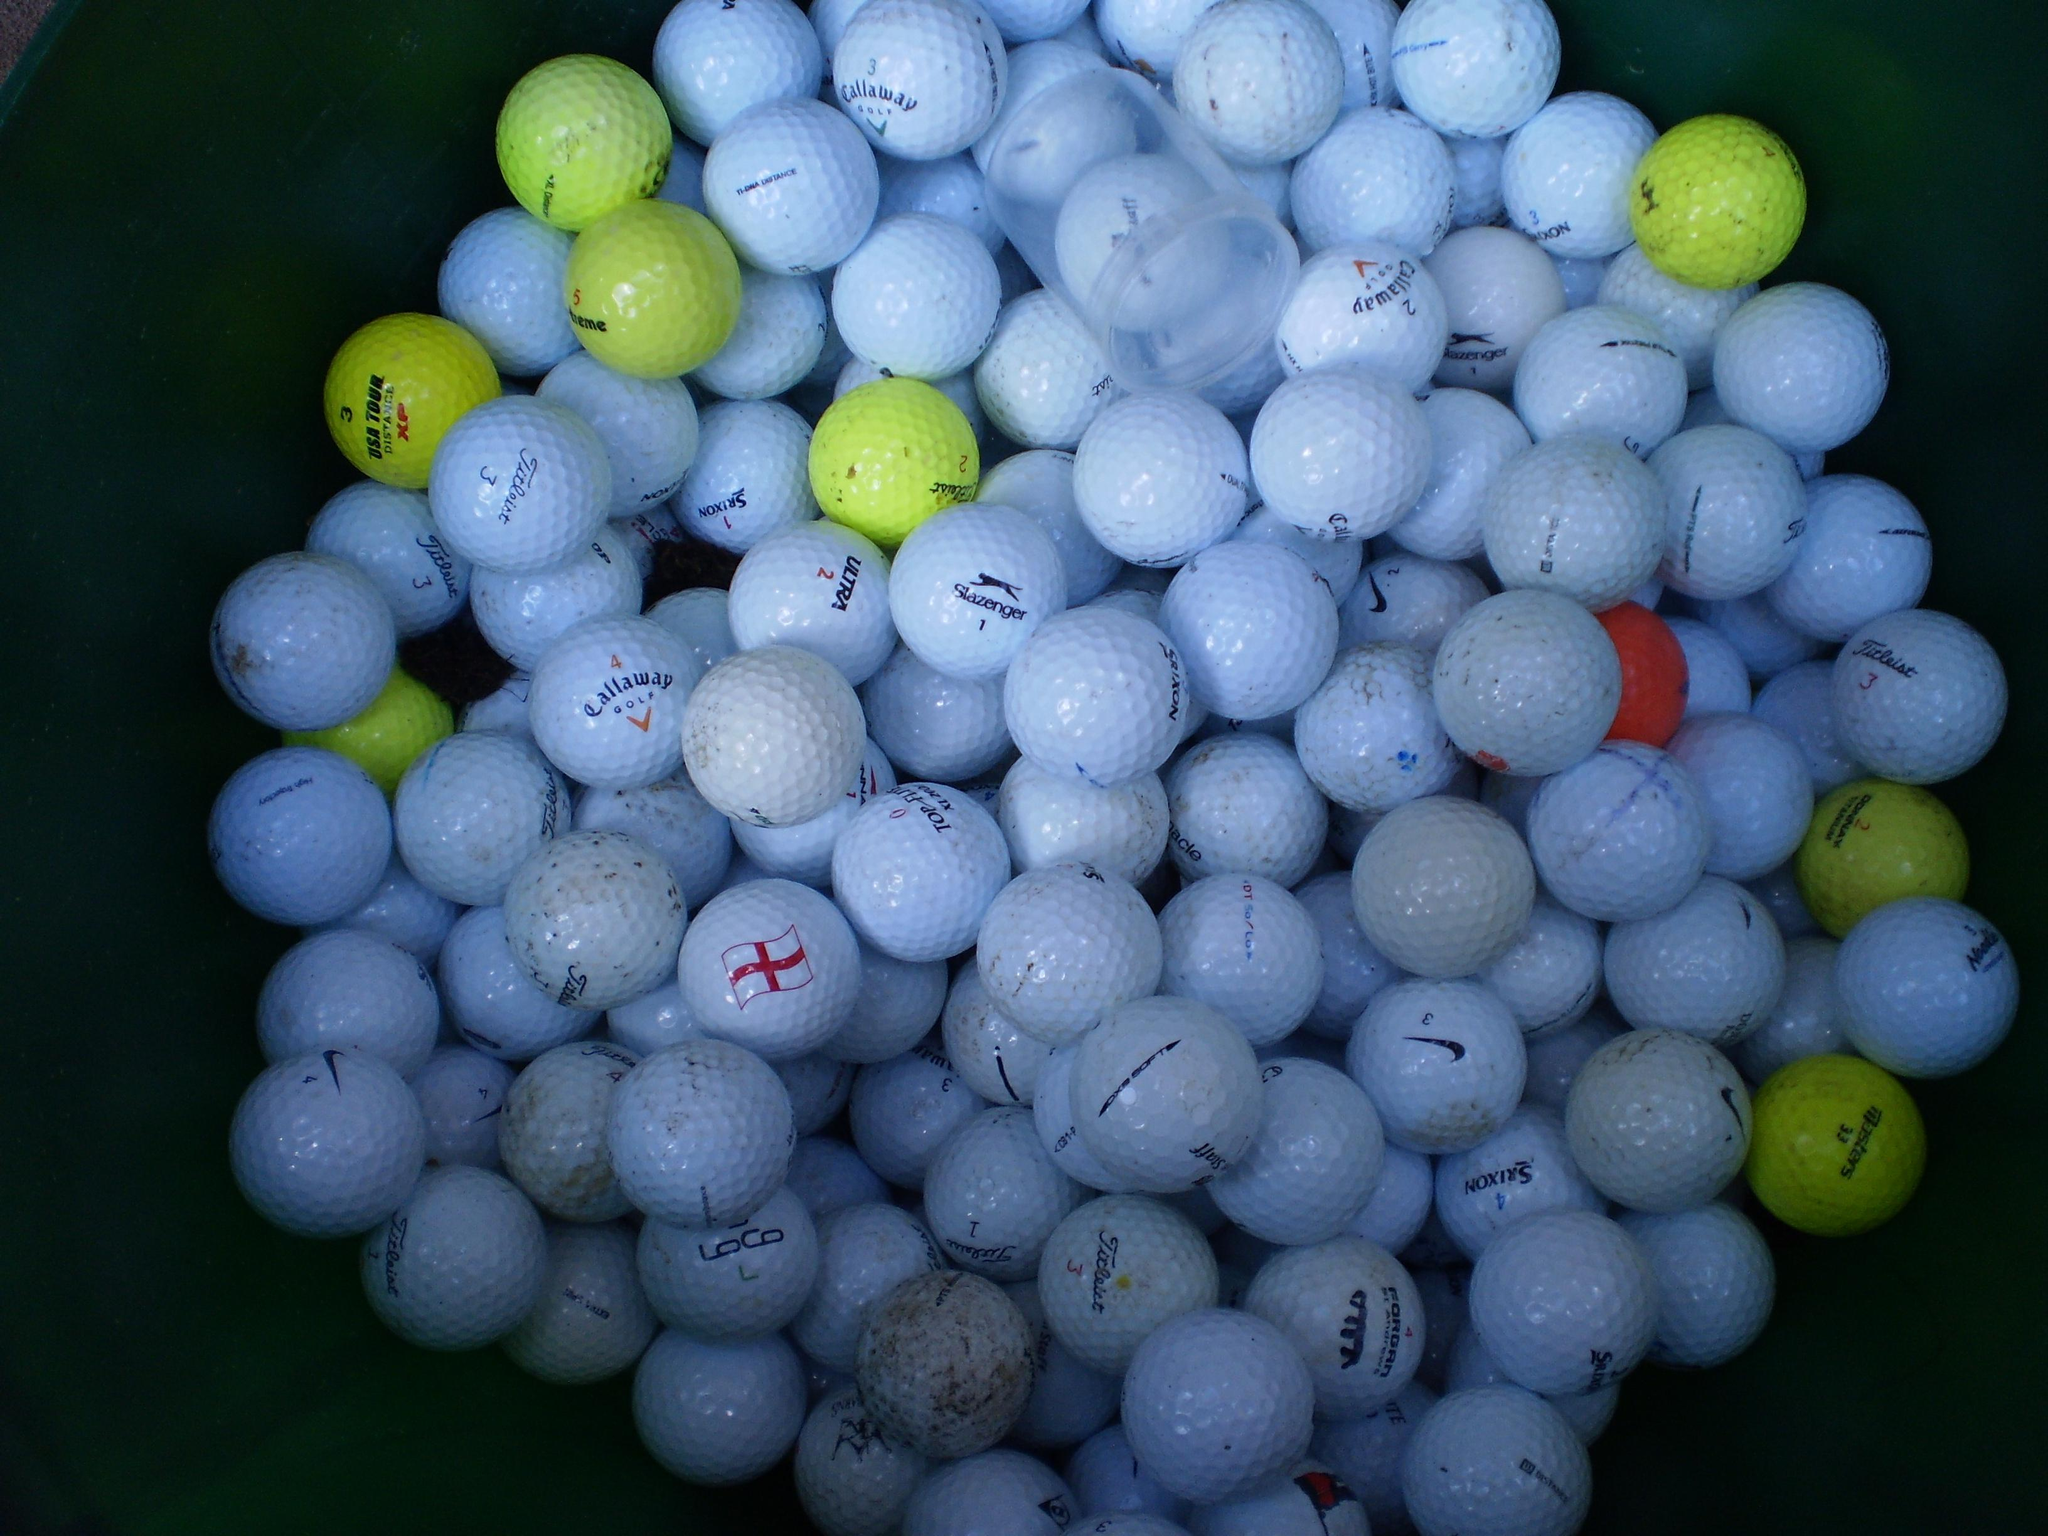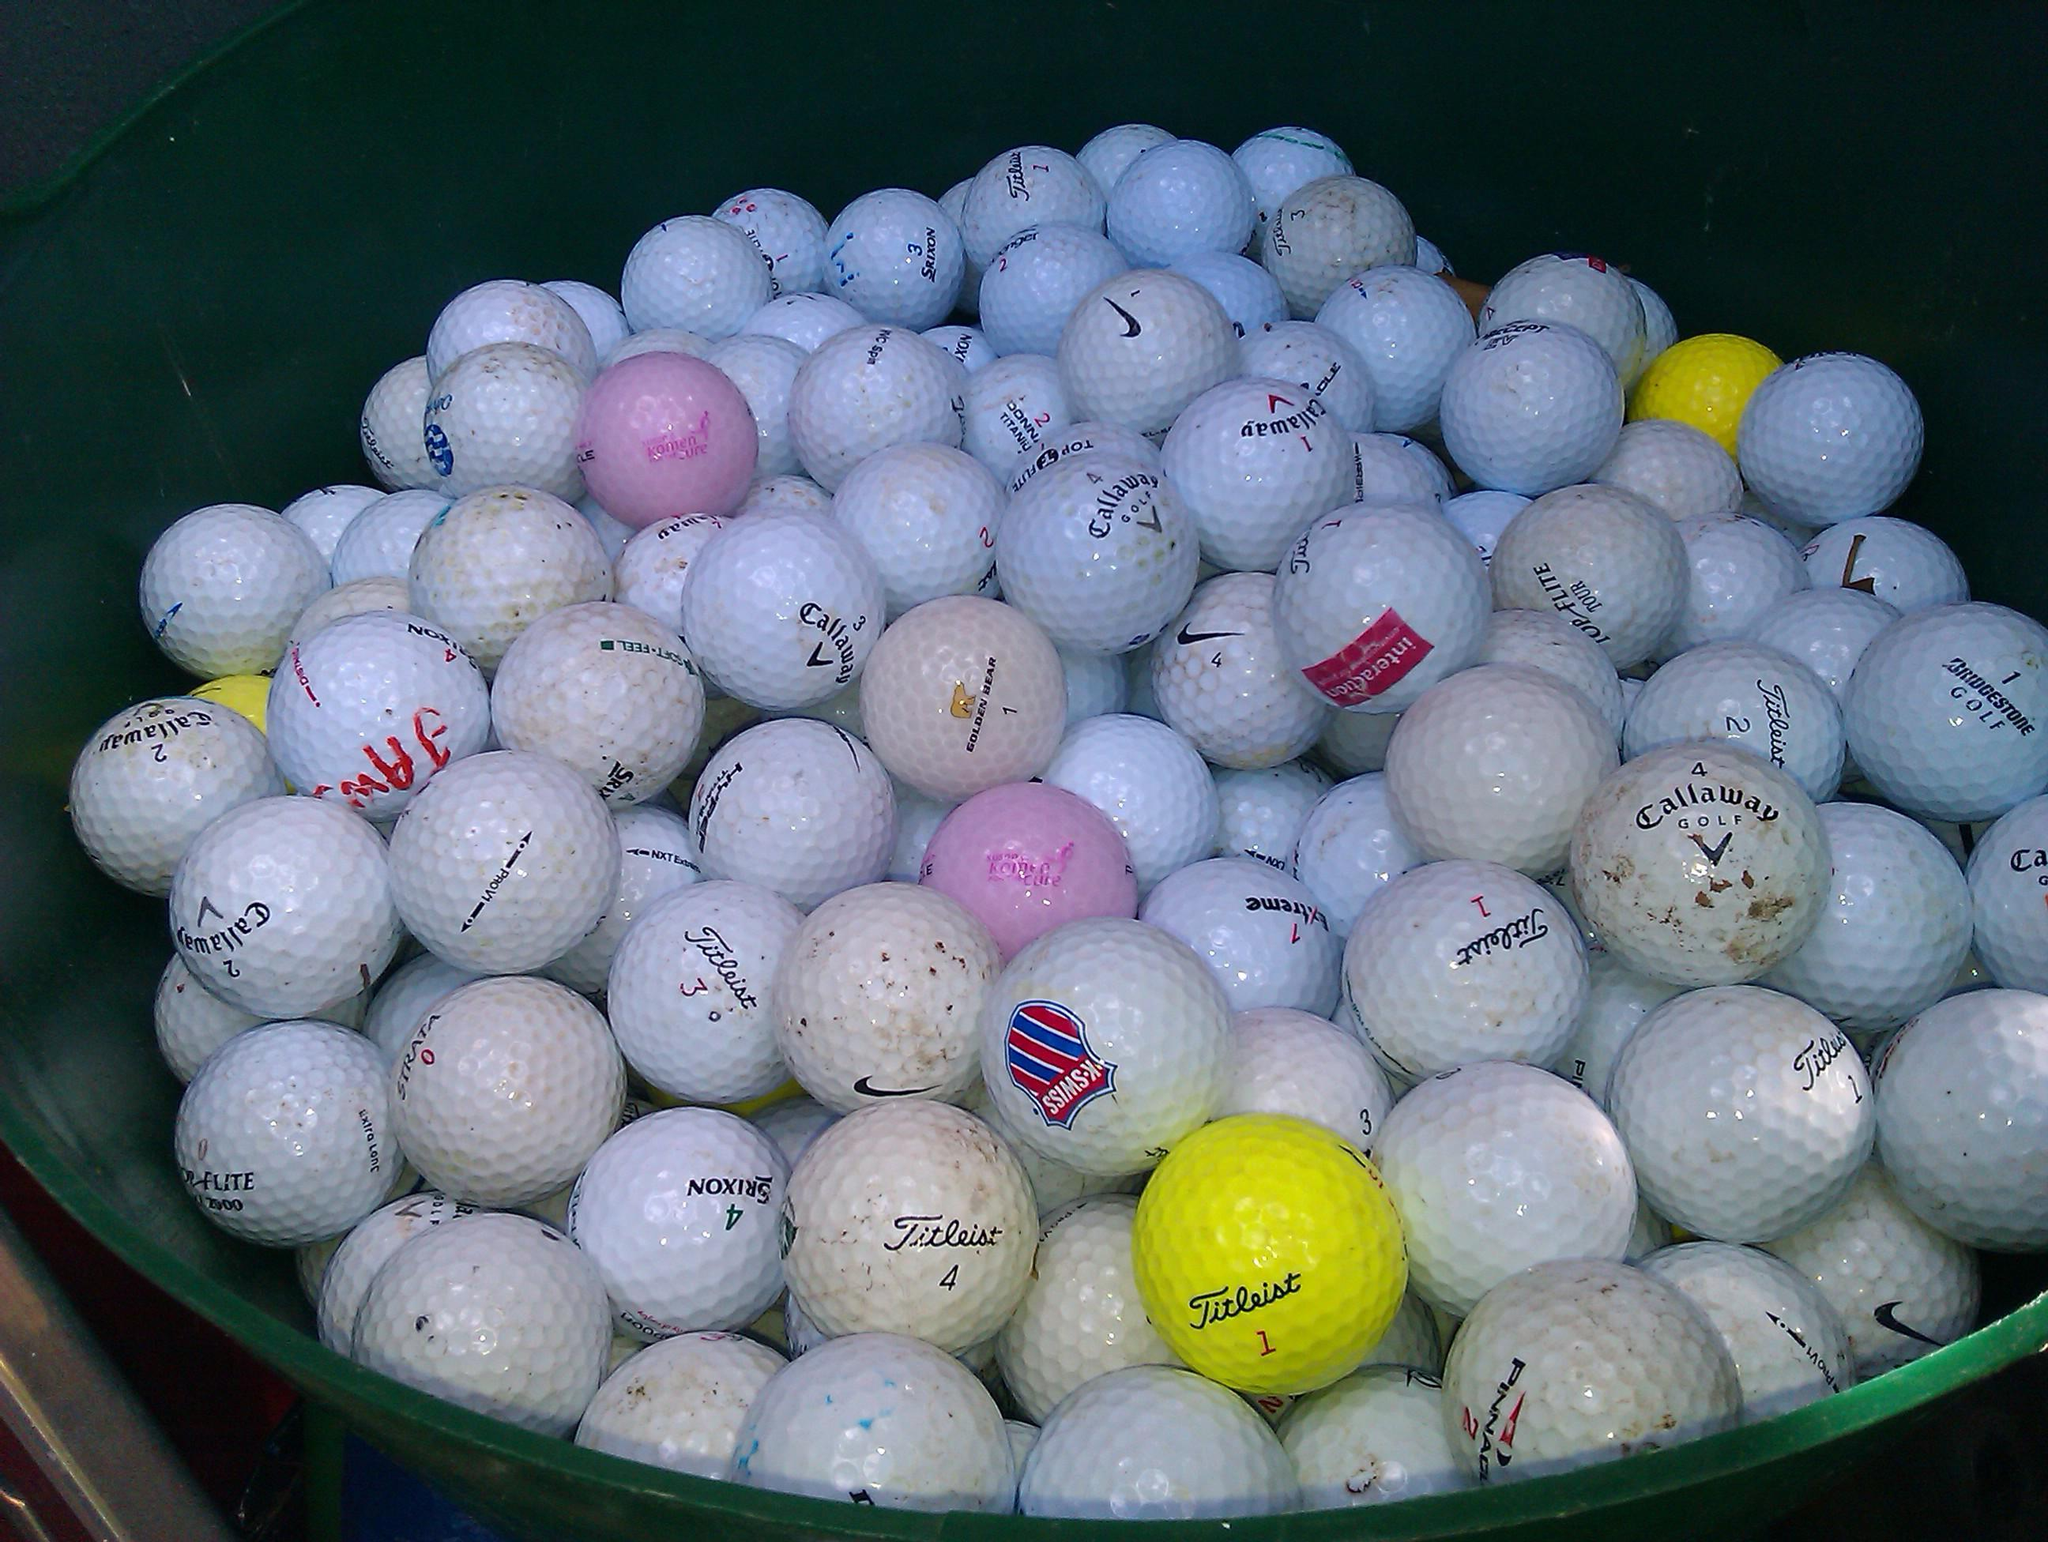The first image is the image on the left, the second image is the image on the right. Examine the images to the left and right. Is the description "In 1 of the images, at least 1 bucket is tipped over." accurate? Answer yes or no. No. The first image is the image on the left, the second image is the image on the right. Considering the images on both sides, is "There is a red golf ball in the pile." valid? Answer yes or no. Yes. 